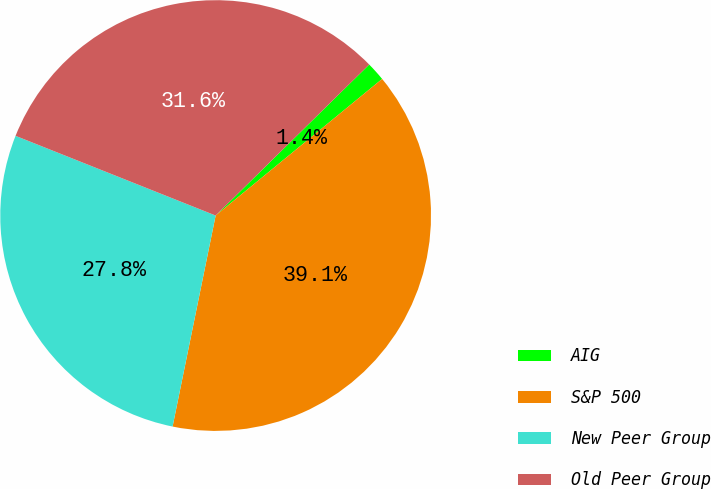Convert chart to OTSL. <chart><loc_0><loc_0><loc_500><loc_500><pie_chart><fcel>AIG<fcel>S&P 500<fcel>New Peer Group<fcel>Old Peer Group<nl><fcel>1.43%<fcel>39.14%<fcel>27.83%<fcel>31.6%<nl></chart> 